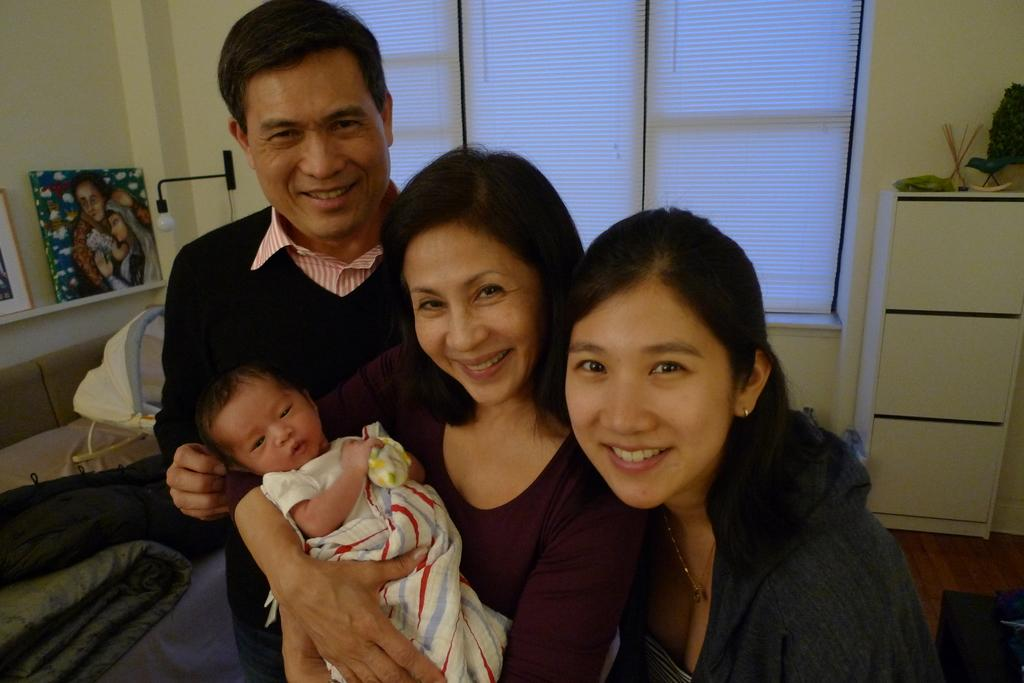How many people are in the image? There are three people standing in the image. What is one person doing with the baby? One person is holding a baby. What items can be seen in the image related to warmth or comfort? Blankets are visible in the image. What type of furniture is present on the shelf in the image? There are frames on a shelf in the image. What architectural feature is present in the image that allows natural light to enter? There is a window in the image. What type of lighting is present in the image? There is a lamp in the image. What type of background is present in the image? There is a wall in the image. What type of storage furniture is present in the image? There is a cupboard in the image. What type of jam is being spread on the map in the image? There is no jam or map present in the image. 